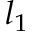<formula> <loc_0><loc_0><loc_500><loc_500>l _ { 1 }</formula> 